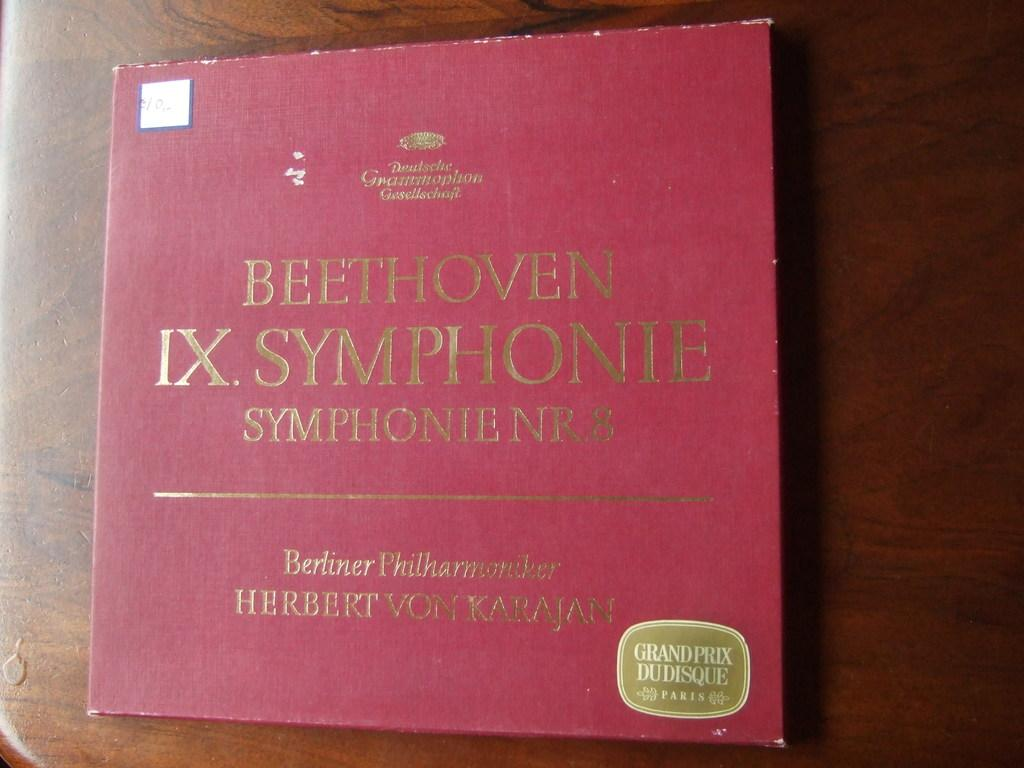Provide a one-sentence caption for the provided image. A Beethoven IX Symphonie record is sitting on a wooden table. 